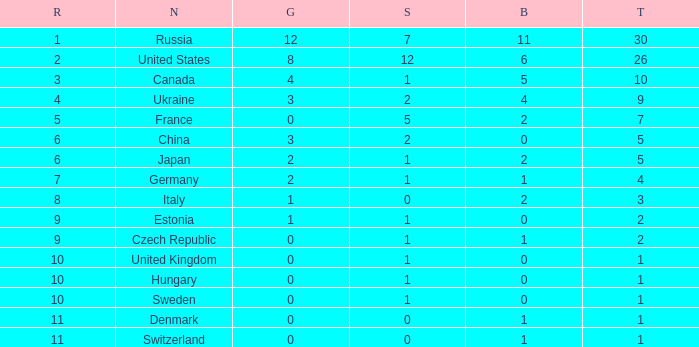Help me parse the entirety of this table. {'header': ['R', 'N', 'G', 'S', 'B', 'T'], 'rows': [['1', 'Russia', '12', '7', '11', '30'], ['2', 'United States', '8', '12', '6', '26'], ['3', 'Canada', '4', '1', '5', '10'], ['4', 'Ukraine', '3', '2', '4', '9'], ['5', 'France', '0', '5', '2', '7'], ['6', 'China', '3', '2', '0', '5'], ['6', 'Japan', '2', '1', '2', '5'], ['7', 'Germany', '2', '1', '1', '4'], ['8', 'Italy', '1', '0', '2', '3'], ['9', 'Estonia', '1', '1', '0', '2'], ['9', 'Czech Republic', '0', '1', '1', '2'], ['10', 'United Kingdom', '0', '1', '0', '1'], ['10', 'Hungary', '0', '1', '0', '1'], ['10', 'Sweden', '0', '1', '0', '1'], ['11', 'Denmark', '0', '0', '1', '1'], ['11', 'Switzerland', '0', '0', '1', '1']]} What is the largest silver with Gold larger than 4, a Nation of united states, and a Total larger than 26? None. 